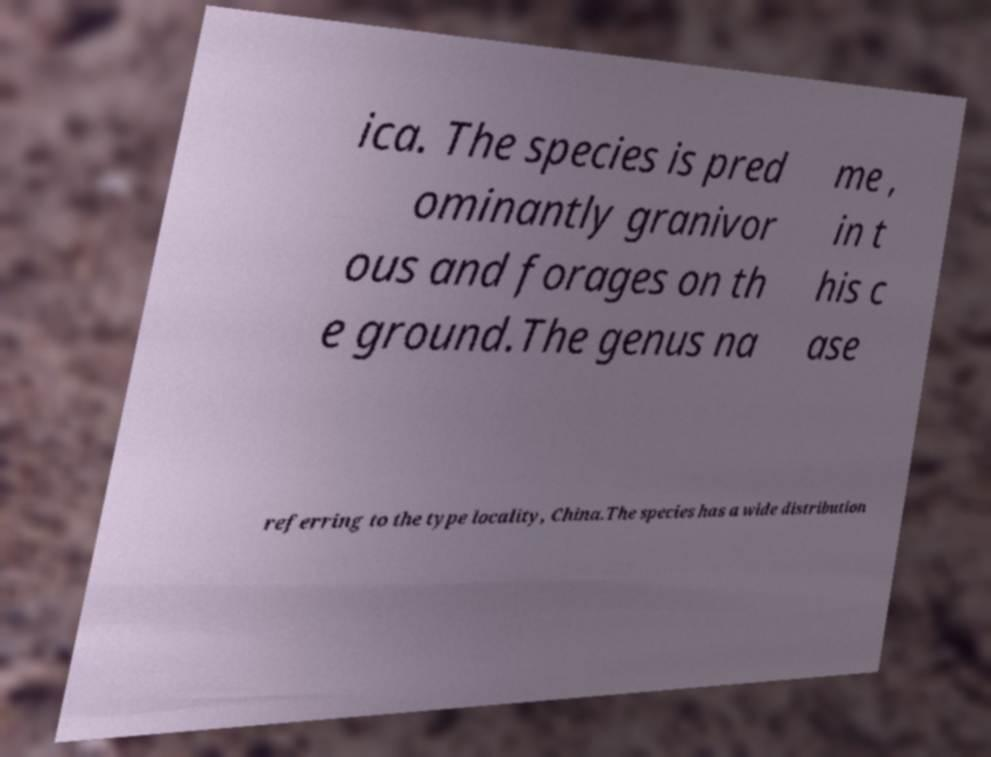Could you extract and type out the text from this image? ica. The species is pred ominantly granivor ous and forages on th e ground.The genus na me , in t his c ase referring to the type locality, China.The species has a wide distribution 